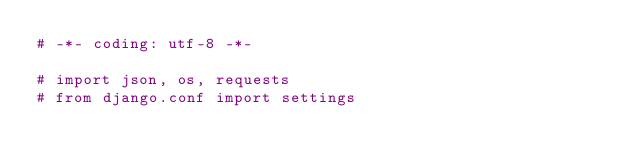<code> <loc_0><loc_0><loc_500><loc_500><_Python_># -*- coding: utf-8 -*-

# import json, os, requests
# from django.conf import settings
</code> 